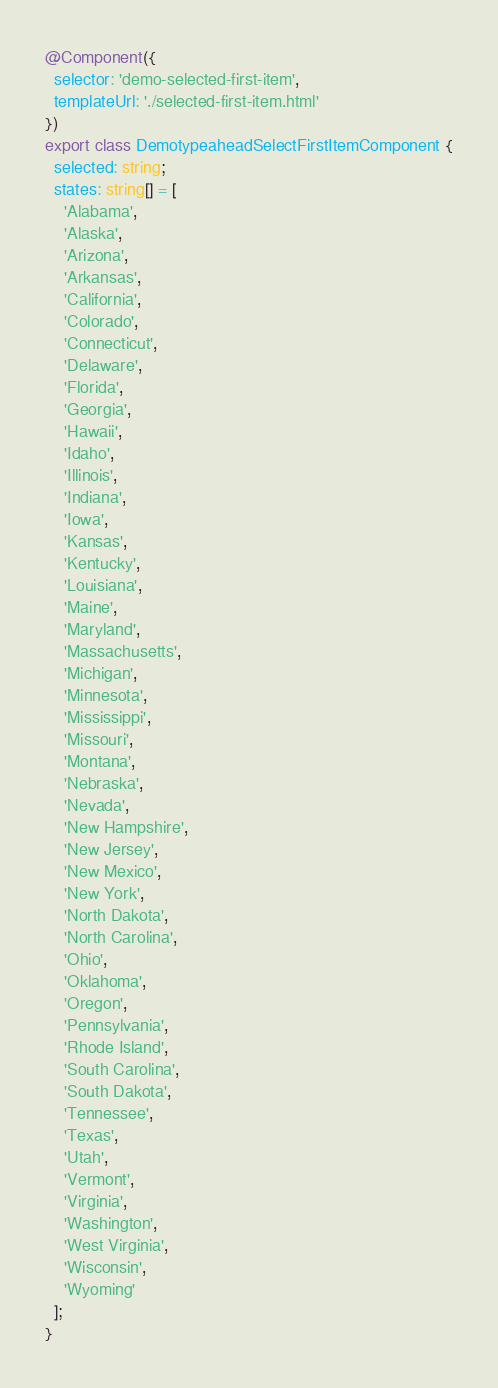<code> <loc_0><loc_0><loc_500><loc_500><_TypeScript_>@Component({
  selector: 'demo-selected-first-item',
  templateUrl: './selected-first-item.html'
})
export class DemotypeaheadSelectFirstItemComponent {
  selected: string;
  states: string[] = [
    'Alabama',
    'Alaska',
    'Arizona',
    'Arkansas',
    'California',
    'Colorado',
    'Connecticut',
    'Delaware',
    'Florida',
    'Georgia',
    'Hawaii',
    'Idaho',
    'Illinois',
    'Indiana',
    'Iowa',
    'Kansas',
    'Kentucky',
    'Louisiana',
    'Maine',
    'Maryland',
    'Massachusetts',
    'Michigan',
    'Minnesota',
    'Mississippi',
    'Missouri',
    'Montana',
    'Nebraska',
    'Nevada',
    'New Hampshire',
    'New Jersey',
    'New Mexico',
    'New York',
    'North Dakota',
    'North Carolina',
    'Ohio',
    'Oklahoma',
    'Oregon',
    'Pennsylvania',
    'Rhode Island',
    'South Carolina',
    'South Dakota',
    'Tennessee',
    'Texas',
    'Utah',
    'Vermont',
    'Virginia',
    'Washington',
    'West Virginia',
    'Wisconsin',
    'Wyoming'
  ];
}
</code> 